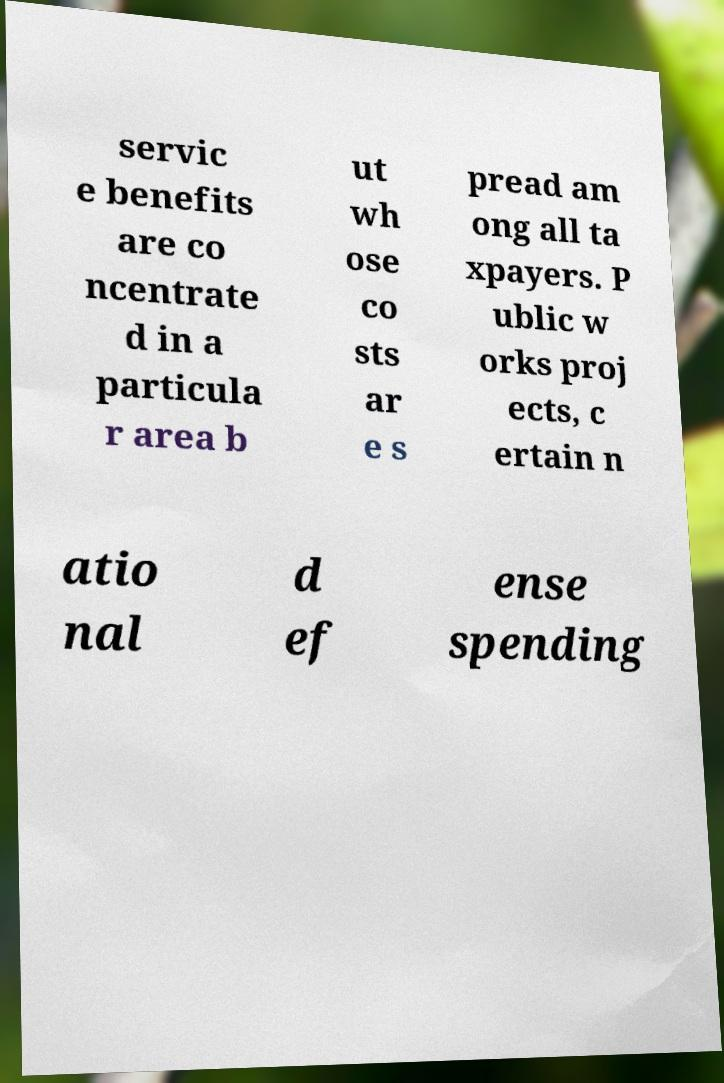Can you accurately transcribe the text from the provided image for me? servic e benefits are co ncentrate d in a particula r area b ut wh ose co sts ar e s pread am ong all ta xpayers. P ublic w orks proj ects, c ertain n atio nal d ef ense spending 